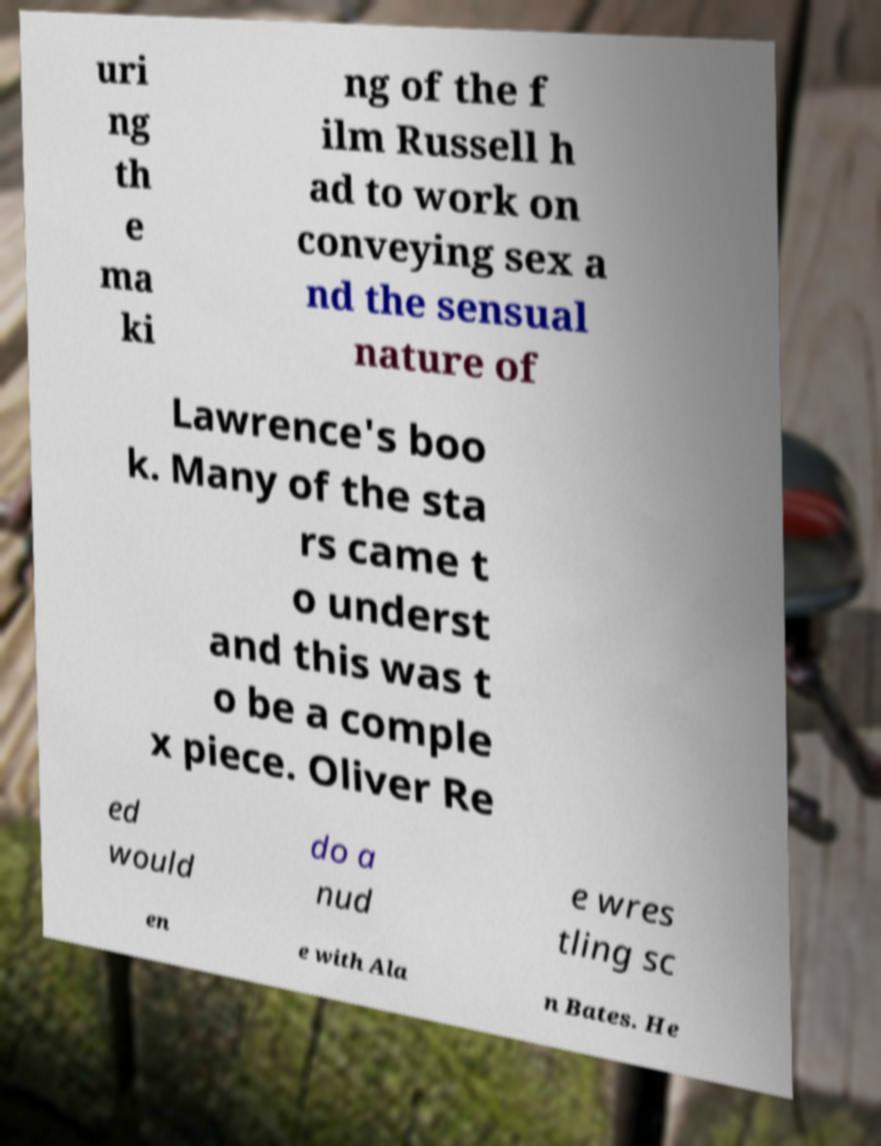Can you accurately transcribe the text from the provided image for me? uri ng th e ma ki ng of the f ilm Russell h ad to work on conveying sex a nd the sensual nature of Lawrence's boo k. Many of the sta rs came t o underst and this was t o be a comple x piece. Oliver Re ed would do a nud e wres tling sc en e with Ala n Bates. He 